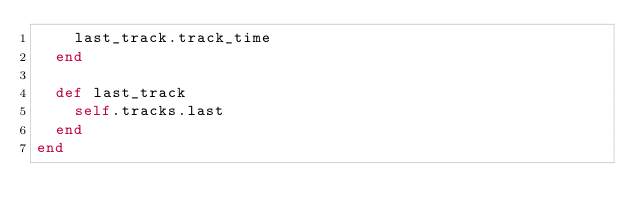<code> <loc_0><loc_0><loc_500><loc_500><_Ruby_>    last_track.track_time
  end

  def last_track
    self.tracks.last
  end
end
</code> 